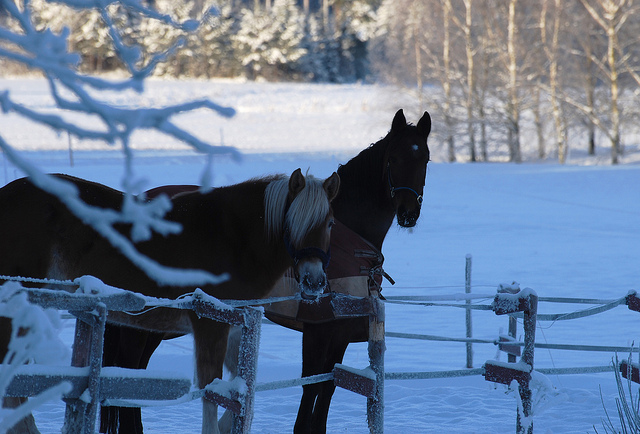Can you describe the setting where these horses are? The horses are standing in a tranquil, snowy field. The trees in the background are bare, suggesting it's winter. The fence is lightly dusted with frost, indicating freezing temperatures outside. What might be the behavior of the horses in such cold weather? In cold weather, horses might display increased need for shelter and warmth, and they can often be seen huddling together for body warmth, which appears to be what they are doing in this image. 